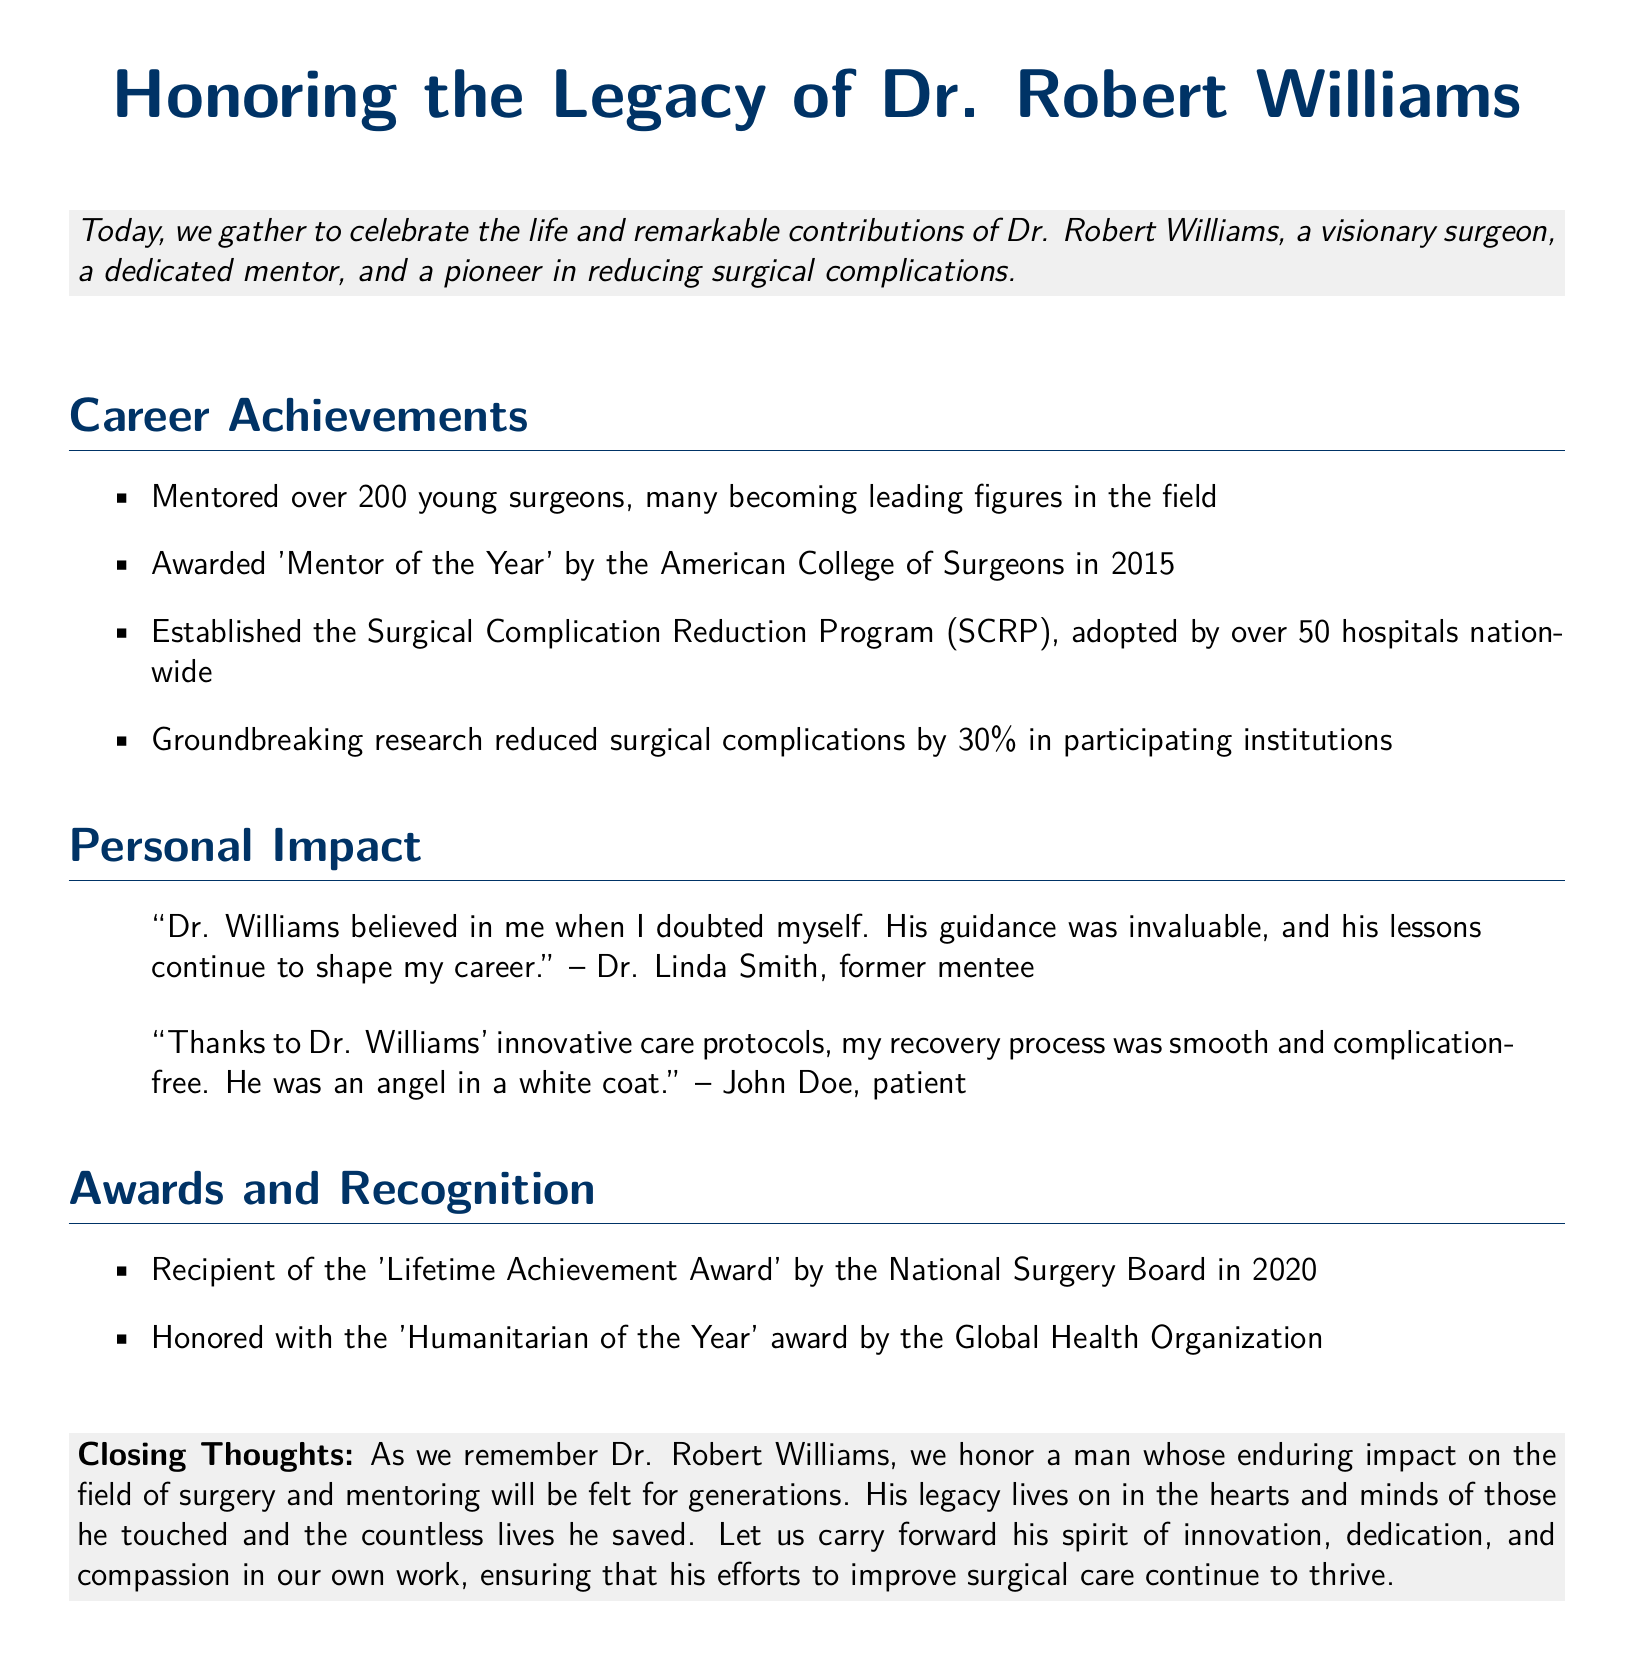What year was Dr. Robert Williams awarded 'Mentor of the Year'? The document states that Dr. Williams received the 'Mentor of the Year' award in 2015.
Answer: 2015 How many young surgeons did Dr. Williams mentor? The document mentions that Dr. Williams mentored over 200 young surgeons.
Answer: over 200 What percentage reduction in surgical complications was achieved by Dr. Williams' research? According to the document, the groundbreaking research led to a 30% reduction in surgical complications.
Answer: 30% What award did Dr. Williams receive in 2020? The document lists 'Lifetime Achievement Award' by the National Surgery Board as the award received in 2020.
Answer: Lifetime Achievement Award Which program did Dr. Williams establish? The document refers to the 'Surgical Complication Reduction Program' that Dr. Williams established.
Answer: Surgical Complication Reduction Program What is the main theme of the closing thoughts? The closing thoughts focus on honoring Dr. Williams' impact on surgery and mentoring.
Answer: Honoring Dr. Williams' impact Who described Dr. Williams as "an angel in a white coat"? The document attributes this description to a patient named John Doe.
Answer: John Doe How many hospitals adopted the Surgical Complication Reduction Program? The document states that over 50 hospitals nationwide adopted the program.
Answer: over 50 hospitals What phrase encapsulates Dr. Williams' approach according to the document? The document describes Dr. Williams' efforts with the phrase "spirit of innovation, dedication, and compassion."
Answer: spirit of innovation, dedication, and compassion 